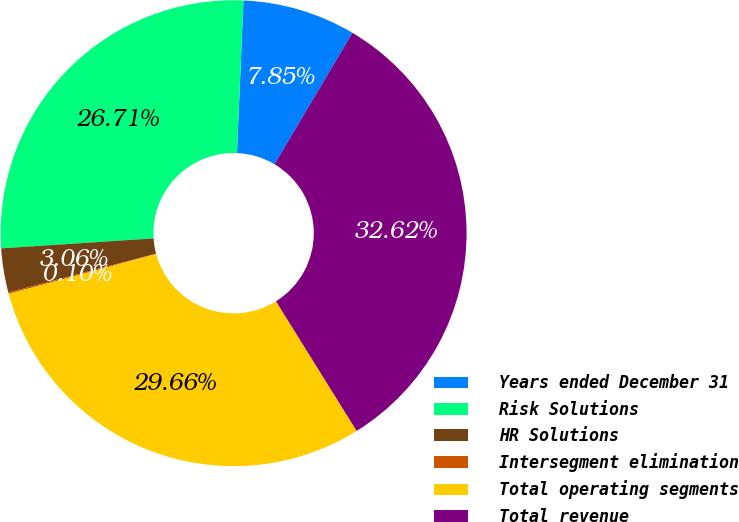Convert chart to OTSL. <chart><loc_0><loc_0><loc_500><loc_500><pie_chart><fcel>Years ended December 31<fcel>Risk Solutions<fcel>HR Solutions<fcel>Intersegment elimination<fcel>Total operating segments<fcel>Total revenue<nl><fcel>7.85%<fcel>26.71%<fcel>3.06%<fcel>0.1%<fcel>29.66%<fcel>32.62%<nl></chart> 